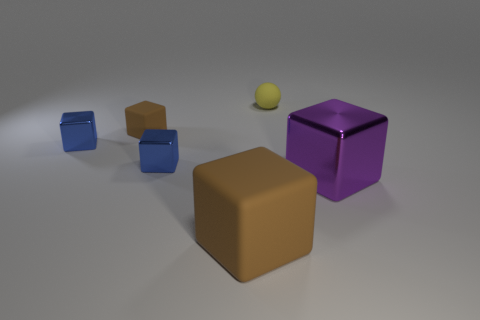Subtract all rubber blocks. How many blocks are left? 3 Add 2 big purple cubes. How many objects exist? 8 Subtract all blue blocks. How many blocks are left? 3 Subtract all cubes. How many objects are left? 1 Subtract 1 balls. How many balls are left? 0 Subtract all cyan cubes. Subtract all red balls. How many cubes are left? 5 Subtract all cyan cubes. How many red spheres are left? 0 Subtract all blue shiny cubes. Subtract all metal things. How many objects are left? 1 Add 5 tiny blue metal objects. How many tiny blue metal objects are left? 7 Add 5 red spheres. How many red spheres exist? 5 